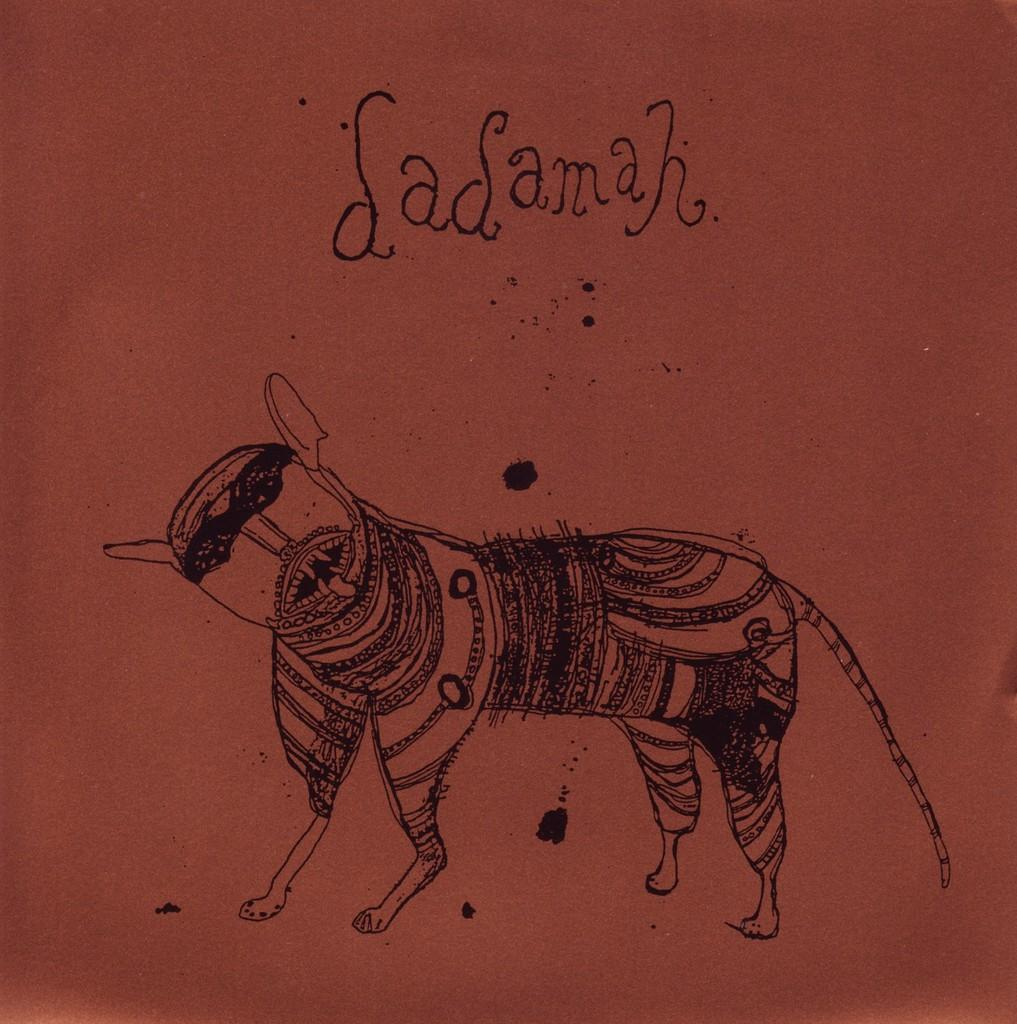What is the main feature of the image? There is a drawing in the image. What else can be seen in the image besides the drawing? There is text in the image. How many people are involved in the fight depicted in the image? There is no fight depicted in the image; it features a drawing and text. On which side of the image is the waste container located? There is no waste container present in the image. 